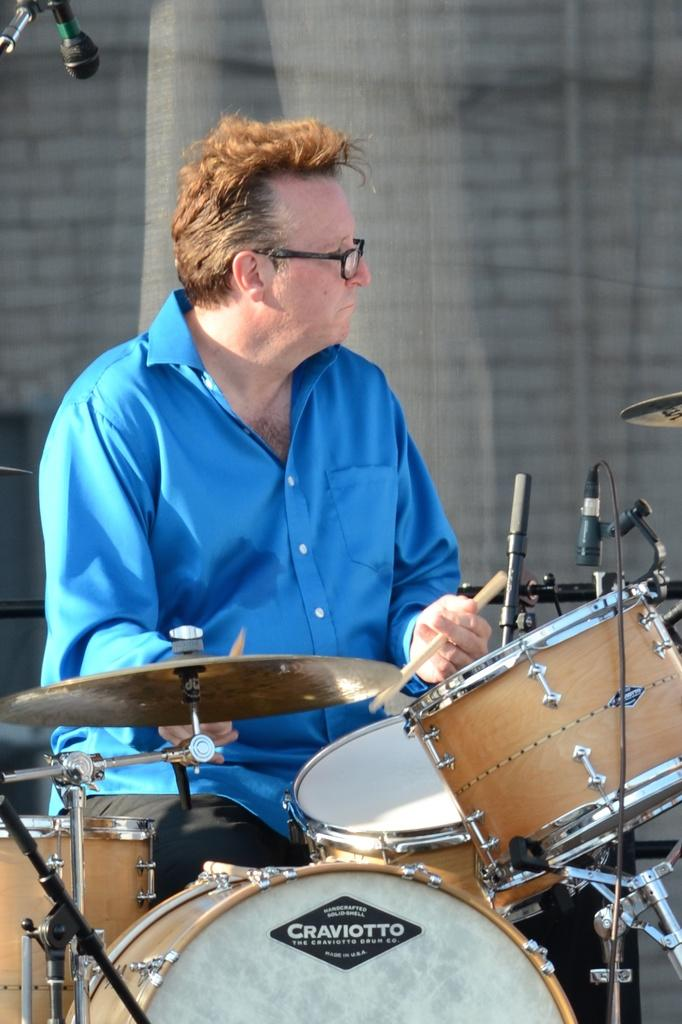What is the man in the image doing? The man is playing musical instruments in the image. What object is present that might be used for amplifying his voice? There is a microphone (mike) in the image. What can be seen in the background of the image? There is a wall visible in the background of the image. How many mice are visible on the wall in the image? There are no mice visible on the wall in the image. What type of thumb can be seen playing the musical instruments in the image? There is no thumb playing the musical instruments in the image; it is a man's hands that are playing them. 